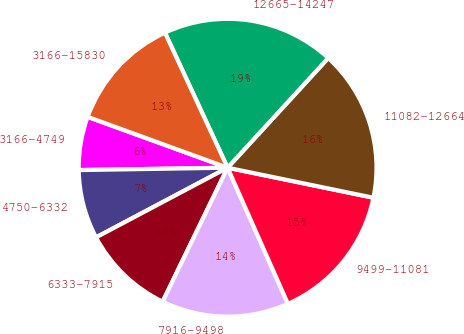Convert chart. <chart><loc_0><loc_0><loc_500><loc_500><pie_chart><fcel>3166-4749<fcel>4750-6332<fcel>6333-7915<fcel>7916-9498<fcel>9499-11081<fcel>11082-12664<fcel>12665-14247<fcel>3166-15830<nl><fcel>5.8%<fcel>7.5%<fcel>10.06%<fcel>13.83%<fcel>15.13%<fcel>16.42%<fcel>18.73%<fcel>12.54%<nl></chart> 